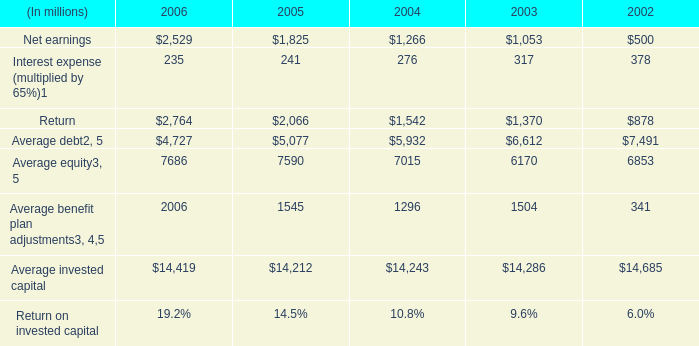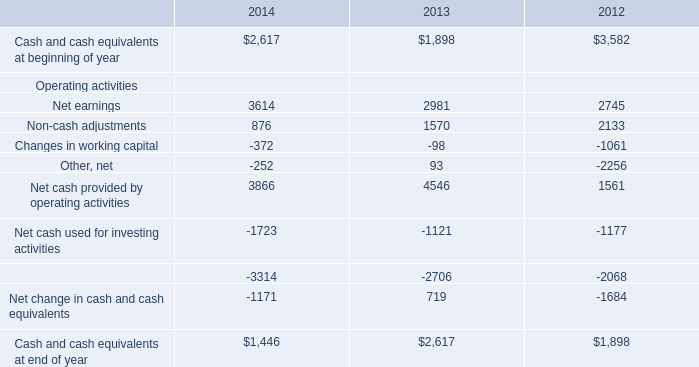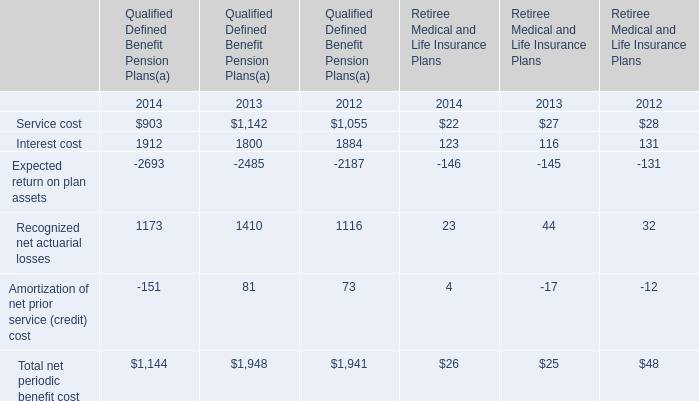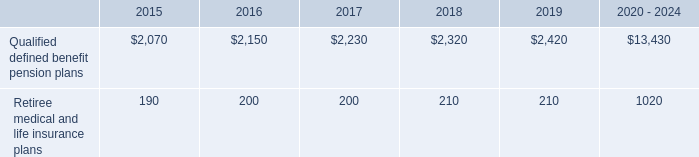What is the sum of Average equity of 2004, and Net earnings Operating activities of 2014 ? 
Computations: (7015.0 + 3614.0)
Answer: 10629.0. 